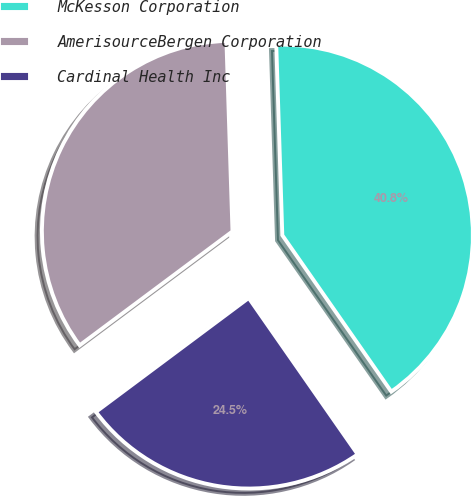Convert chart. <chart><loc_0><loc_0><loc_500><loc_500><pie_chart><fcel>McKesson Corporation<fcel>AmerisourceBergen Corporation<fcel>Cardinal Health Inc<nl><fcel>40.82%<fcel>34.69%<fcel>24.49%<nl></chart> 